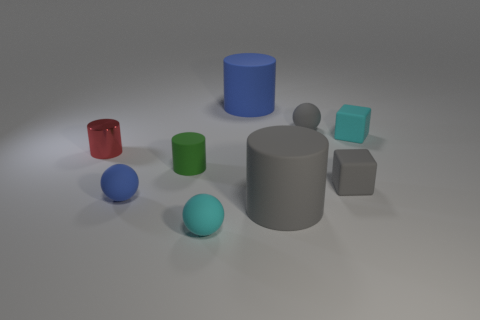Subtract all blue rubber spheres. How many spheres are left? 2 Subtract all red cylinders. How many cylinders are left? 3 Add 1 gray matte balls. How many objects exist? 10 Subtract all blocks. How many objects are left? 7 Subtract 2 cylinders. How many cylinders are left? 2 Subtract all purple cubes. Subtract all cyan cylinders. How many cubes are left? 2 Subtract all yellow cubes. How many purple cylinders are left? 0 Subtract all tiny blue things. Subtract all cyan matte balls. How many objects are left? 7 Add 3 large rubber cylinders. How many large rubber cylinders are left? 5 Add 3 large gray matte objects. How many large gray matte objects exist? 4 